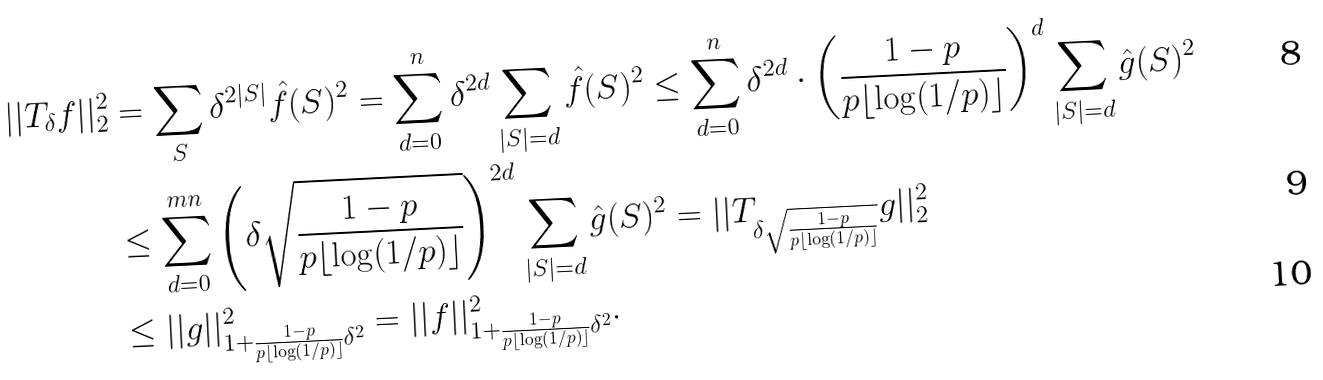<formula> <loc_0><loc_0><loc_500><loc_500>| | T _ { \delta } f | | _ { 2 } ^ { 2 } & = \sum _ { S } \delta ^ { 2 | S | } \hat { f } ( S ) ^ { 2 } = \sum _ { d = 0 } ^ { n } \delta ^ { 2 d } \sum _ { | S | = d } \hat { f } ( S ) ^ { 2 } \leq \sum _ { d = 0 } ^ { n } \delta ^ { 2 d } \cdot \left ( \frac { 1 - p } { p \lfloor \log ( 1 / p ) \rfloor } \right ) ^ { d } \sum _ { | S | = d } \hat { g } ( S ) ^ { 2 } \\ & \leq \sum _ { d = 0 } ^ { m n } \left ( \delta \sqrt { \frac { 1 - p } { p \lfloor \log ( 1 / p ) \rfloor } } \right ) ^ { 2 d } \sum _ { | S | = d } \hat { g } ( S ) ^ { 2 } = | | T _ { \delta \sqrt { \frac { 1 - p } { p \lfloor \log ( 1 / p ) \rfloor } } } g | | _ { 2 } ^ { 2 } \\ & \leq | | g | | _ { 1 + \frac { 1 - p } { p \lfloor \log ( 1 / p ) \rfloor } \delta ^ { 2 } } ^ { 2 } = | | f | | _ { 1 + \frac { 1 - p } { p \lfloor \log ( 1 / p ) \rfloor } \delta ^ { 2 } } ^ { 2 } .</formula> 